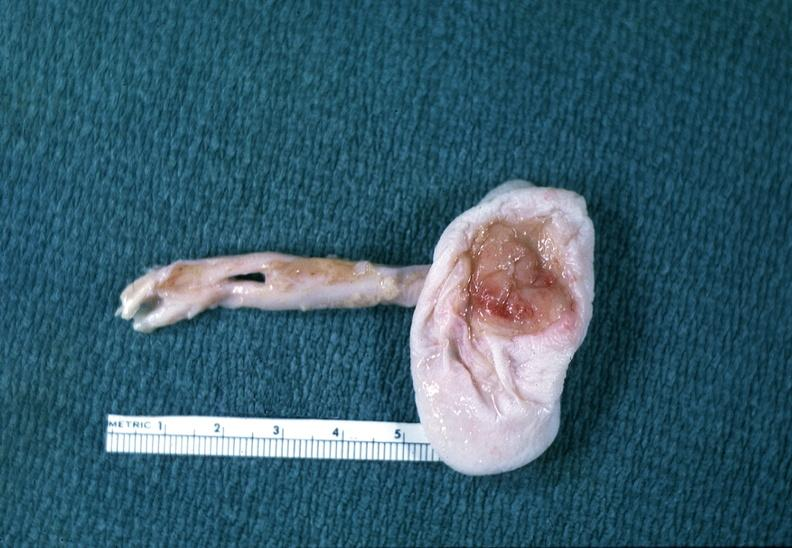does this image show neural tube defect?
Answer the question using a single word or phrase. Yes 